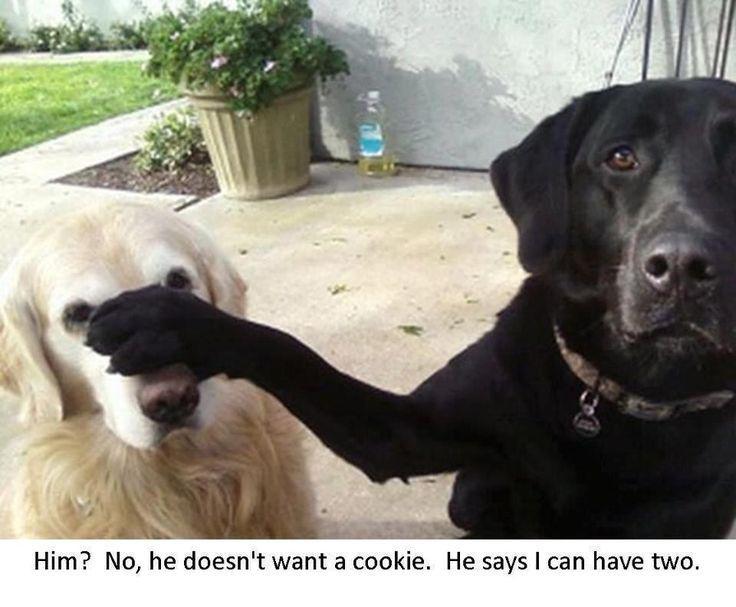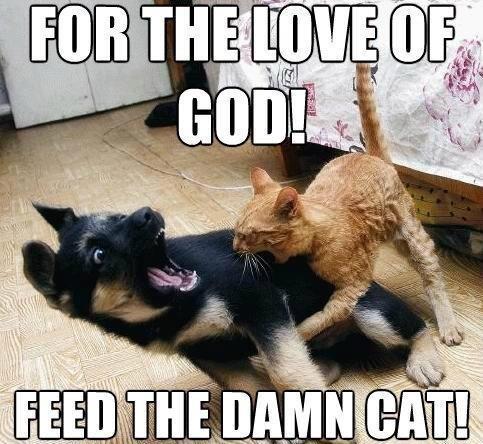The first image is the image on the left, the second image is the image on the right. Given the left and right images, does the statement "There are two dogs in the image on the left." hold true? Answer yes or no. Yes. 